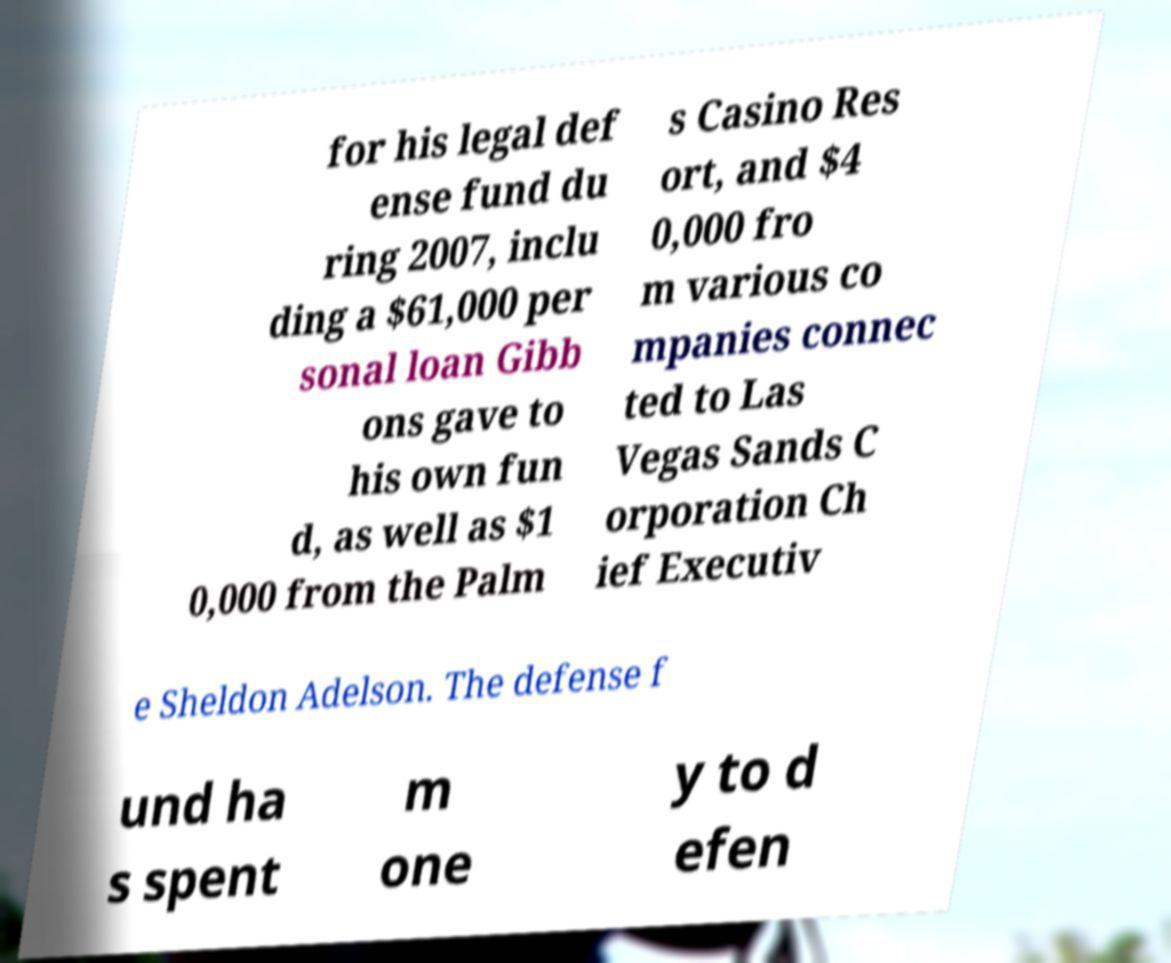Can you read and provide the text displayed in the image?This photo seems to have some interesting text. Can you extract and type it out for me? for his legal def ense fund du ring 2007, inclu ding a $61,000 per sonal loan Gibb ons gave to his own fun d, as well as $1 0,000 from the Palm s Casino Res ort, and $4 0,000 fro m various co mpanies connec ted to Las Vegas Sands C orporation Ch ief Executiv e Sheldon Adelson. The defense f und ha s spent m one y to d efen 